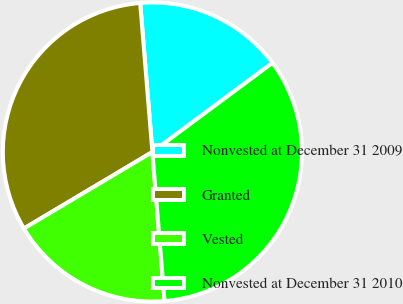Convert chart. <chart><loc_0><loc_0><loc_500><loc_500><pie_chart><fcel>Nonvested at December 31 2009<fcel>Granted<fcel>Vested<fcel>Nonvested at December 31 2010<nl><fcel>16.14%<fcel>32.25%<fcel>17.75%<fcel>33.87%<nl></chart> 